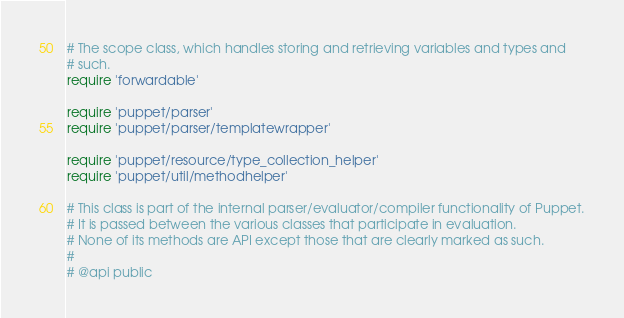Convert code to text. <code><loc_0><loc_0><loc_500><loc_500><_Ruby_># The scope class, which handles storing and retrieving variables and types and
# such.
require 'forwardable'

require 'puppet/parser'
require 'puppet/parser/templatewrapper'

require 'puppet/resource/type_collection_helper'
require 'puppet/util/methodhelper'

# This class is part of the internal parser/evaluator/compiler functionality of Puppet.
# It is passed between the various classes that participate in evaluation.
# None of its methods are API except those that are clearly marked as such.
#
# @api public</code> 